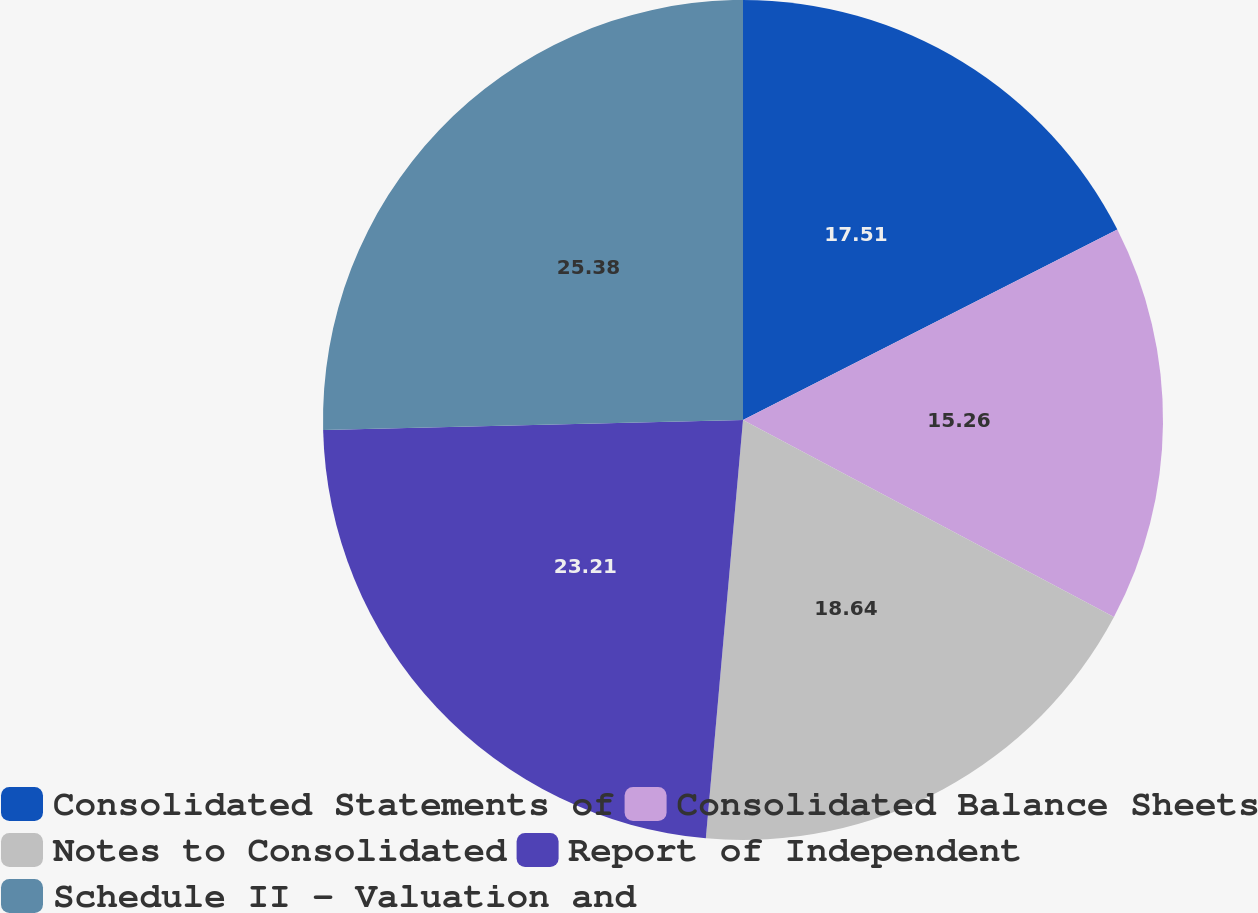Convert chart to OTSL. <chart><loc_0><loc_0><loc_500><loc_500><pie_chart><fcel>Consolidated Statements of<fcel>Consolidated Balance Sheets<fcel>Notes to Consolidated<fcel>Report of Independent<fcel>Schedule II - Valuation and<nl><fcel>17.51%<fcel>15.26%<fcel>18.64%<fcel>23.21%<fcel>25.38%<nl></chart> 